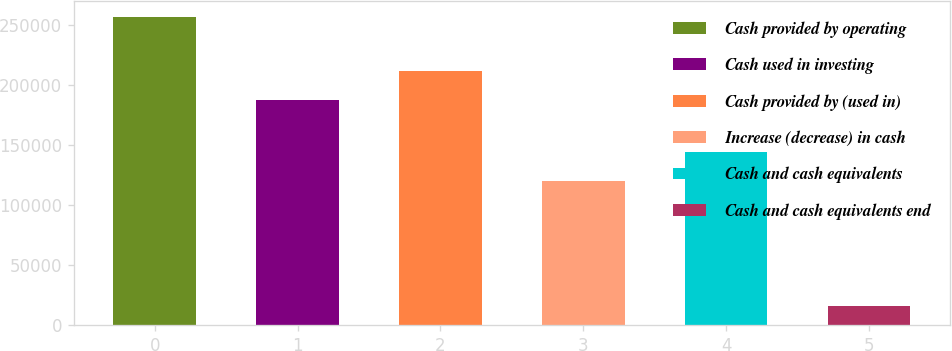<chart> <loc_0><loc_0><loc_500><loc_500><bar_chart><fcel>Cash provided by operating<fcel>Cash used in investing<fcel>Cash provided by (used in)<fcel>Increase (decrease) in cash<fcel>Cash and cash equivalents<fcel>Cash and cash equivalents end<nl><fcel>256735<fcel>187088<fcel>211182<fcel>119592<fcel>143686<fcel>15797<nl></chart> 